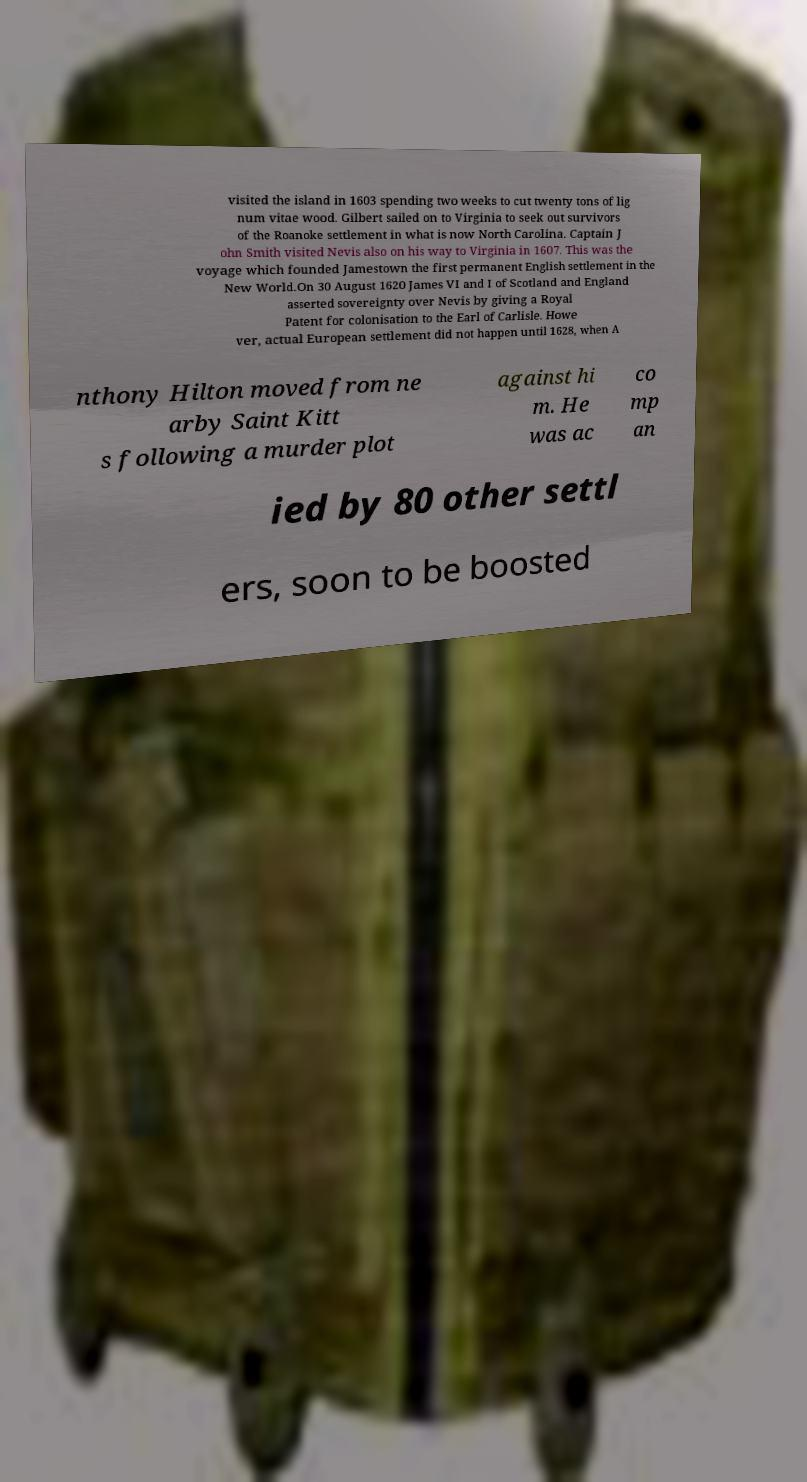Could you assist in decoding the text presented in this image and type it out clearly? visited the island in 1603 spending two weeks to cut twenty tons of lig num vitae wood. Gilbert sailed on to Virginia to seek out survivors of the Roanoke settlement in what is now North Carolina. Captain J ohn Smith visited Nevis also on his way to Virginia in 1607. This was the voyage which founded Jamestown the first permanent English settlement in the New World.On 30 August 1620 James VI and I of Scotland and England asserted sovereignty over Nevis by giving a Royal Patent for colonisation to the Earl of Carlisle. Howe ver, actual European settlement did not happen until 1628, when A nthony Hilton moved from ne arby Saint Kitt s following a murder plot against hi m. He was ac co mp an ied by 80 other settl ers, soon to be boosted 